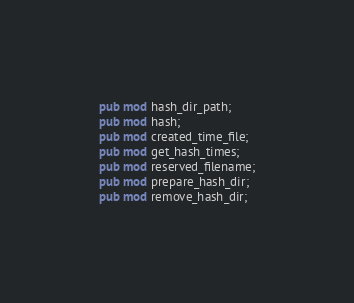<code> <loc_0><loc_0><loc_500><loc_500><_Rust_>pub mod hash_dir_path;
pub mod hash;
pub mod created_time_file;
pub mod get_hash_times;
pub mod reserved_filename;
pub mod prepare_hash_dir;
pub mod remove_hash_dir;

</code> 